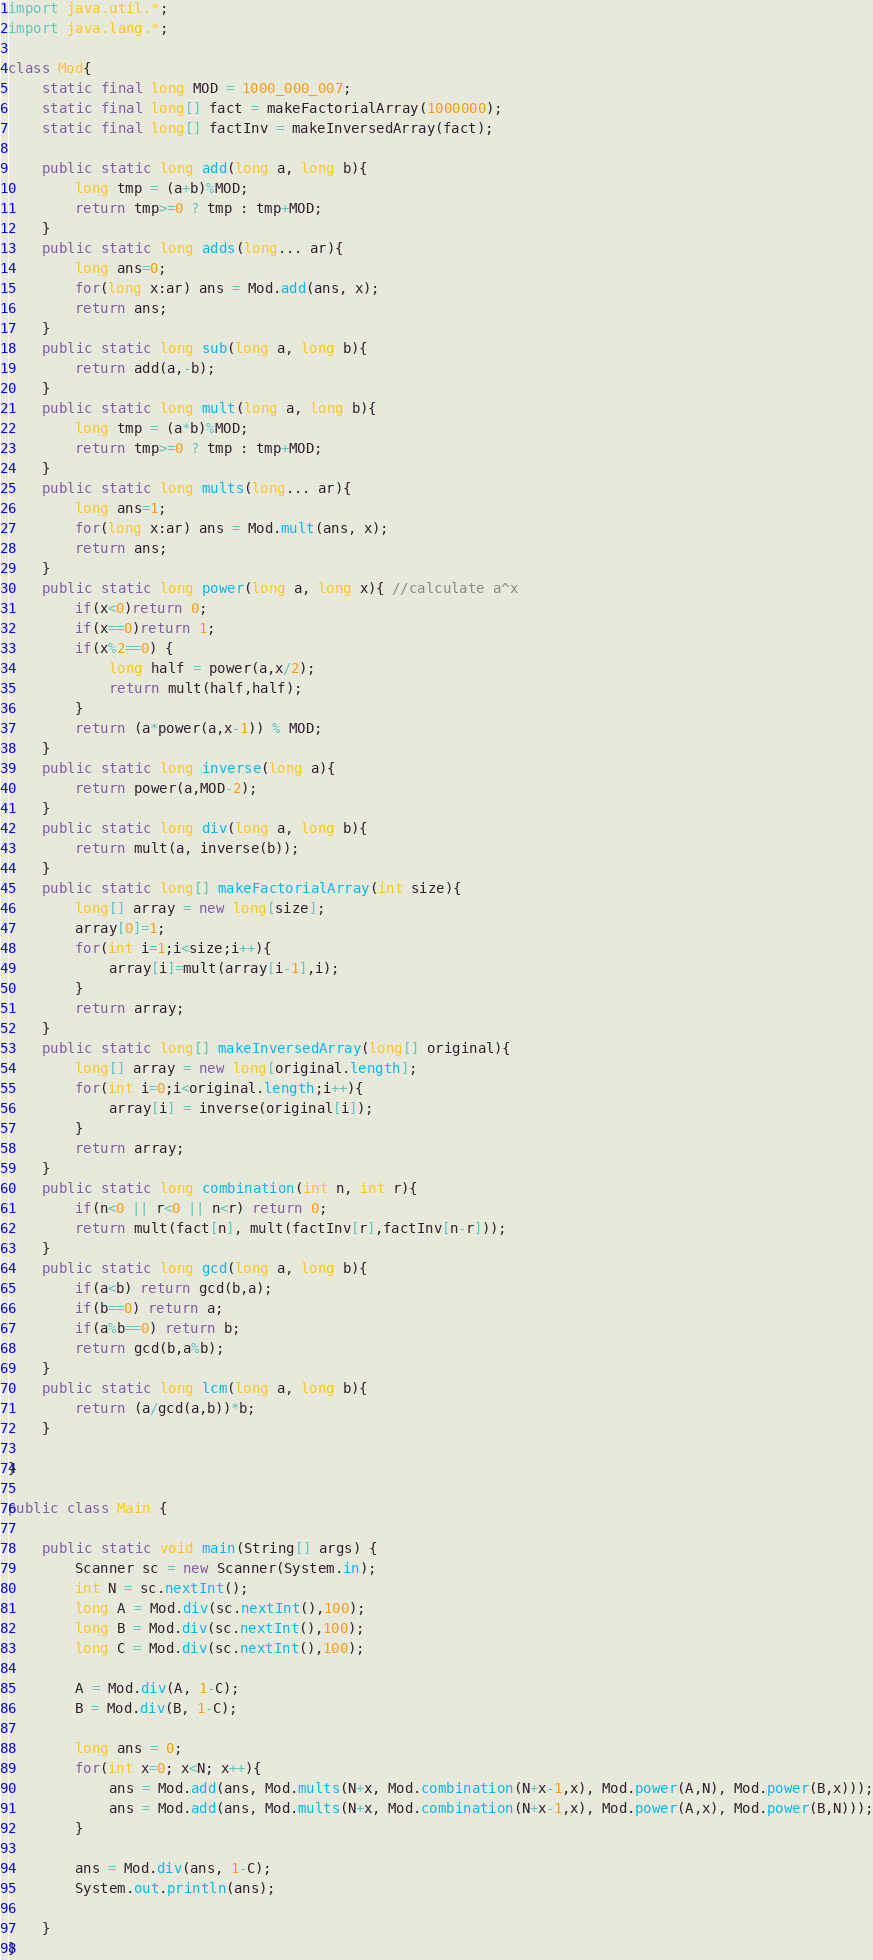<code> <loc_0><loc_0><loc_500><loc_500><_Java_>import java.util.*;
import java.lang.*;

class Mod{
    static final long MOD = 1000_000_007;
    static final long[] fact = makeFactorialArray(1000000);
    static final long[] factInv = makeInversedArray(fact);

    public static long add(long a, long b){
        long tmp = (a+b)%MOD;
        return tmp>=0 ? tmp : tmp+MOD;
    }
    public static long adds(long... ar){
        long ans=0;
        for(long x:ar) ans = Mod.add(ans, x);
        return ans;
    }
    public static long sub(long a, long b){
        return add(a,-b);
    }
    public static long mult(long a, long b){
        long tmp = (a*b)%MOD;
        return tmp>=0 ? tmp : tmp+MOD;
    }
    public static long mults(long... ar){
        long ans=1;
        for(long x:ar) ans = Mod.mult(ans, x);
        return ans;
    }
    public static long power(long a, long x){ //calculate a^x
        if(x<0)return 0;
        if(x==0)return 1;
        if(x%2==0) {
            long half = power(a,x/2);
            return mult(half,half);
        }
        return (a*power(a,x-1)) % MOD;
    }
    public static long inverse(long a){
        return power(a,MOD-2);
    }
    public static long div(long a, long b){
        return mult(a, inverse(b));
    }
    public static long[] makeFactorialArray(int size){
        long[] array = new long[size];
        array[0]=1;
        for(int i=1;i<size;i++){
            array[i]=mult(array[i-1],i);
        }
        return array;
    }
    public static long[] makeInversedArray(long[] original){
        long[] array = new long[original.length];
        for(int i=0;i<original.length;i++){
            array[i] = inverse(original[i]);
        }
        return array;
    }
    public static long combination(int n, int r){
        if(n<0 || r<0 || n<r) return 0;
        return mult(fact[n], mult(factInv[r],factInv[n-r]));
    }
    public static long gcd(long a, long b){
        if(a<b) return gcd(b,a);
        if(b==0) return a;
        if(a%b==0) return b;
        return gcd(b,a%b);
    }
    public static long lcm(long a, long b){
        return (a/gcd(a,b))*b;
    }

}

public class Main {

    public static void main(String[] args) {
        Scanner sc = new Scanner(System.in);
        int N = sc.nextInt();
        long A = Mod.div(sc.nextInt(),100);
        long B = Mod.div(sc.nextInt(),100);
        long C = Mod.div(sc.nextInt(),100);

        A = Mod.div(A, 1-C);
        B = Mod.div(B, 1-C);

        long ans = 0;
        for(int x=0; x<N; x++){
            ans = Mod.add(ans, Mod.mults(N+x, Mod.combination(N+x-1,x), Mod.power(A,N), Mod.power(B,x)));
            ans = Mod.add(ans, Mod.mults(N+x, Mod.combination(N+x-1,x), Mod.power(A,x), Mod.power(B,N)));
        }

        ans = Mod.div(ans, 1-C);
        System.out.println(ans);

    }
}</code> 